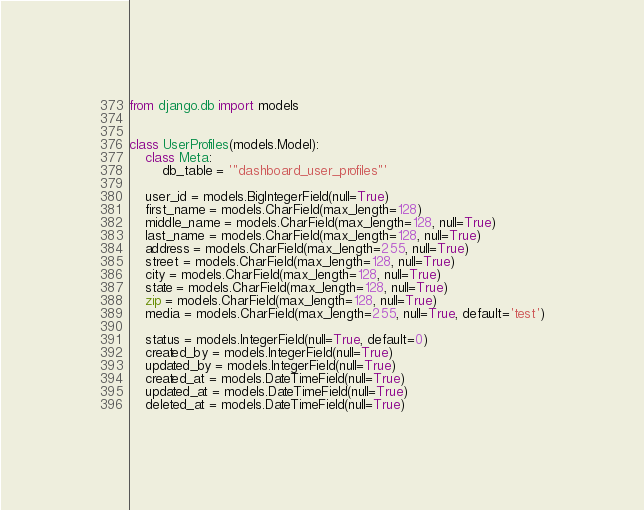Convert code to text. <code><loc_0><loc_0><loc_500><loc_500><_Python_>from django.db import models


class UserProfiles(models.Model):
    class Meta:
        db_table = '"dashboard_user_profiles"'

    user_id = models.BigIntegerField(null=True)
    first_name = models.CharField(max_length=128)
    middle_name = models.CharField(max_length=128, null=True)
    last_name = models.CharField(max_length=128, null=True)
    address = models.CharField(max_length=255, null=True)
    street = models.CharField(max_length=128, null=True)
    city = models.CharField(max_length=128, null=True)
    state = models.CharField(max_length=128, null=True)
    zip = models.CharField(max_length=128, null=True)
    media = models.CharField(max_length=255, null=True, default='test')

    status = models.IntegerField(null=True, default=0)
    created_by = models.IntegerField(null=True)
    updated_by = models.IntegerField(null=True)
    created_at = models.DateTimeField(null=True)
    updated_at = models.DateTimeField(null=True)
    deleted_at = models.DateTimeField(null=True)
</code> 